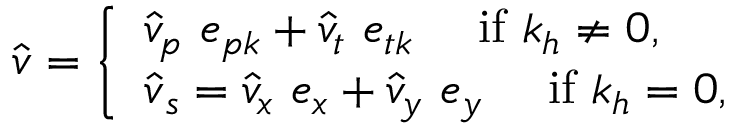Convert formula to latex. <formula><loc_0><loc_0><loc_500><loc_500>\hat { v } = \left \{ \begin{array} { l l } { \hat { v } _ { p } e _ { p k } + \hat { v } _ { t } e _ { t k } i f k _ { h } \neq 0 , } \\ { \hat { v } _ { s } = \hat { v } _ { x } e _ { x } + \hat { v } _ { y } e _ { y } i f k _ { h } = 0 , } \end{array}</formula> 